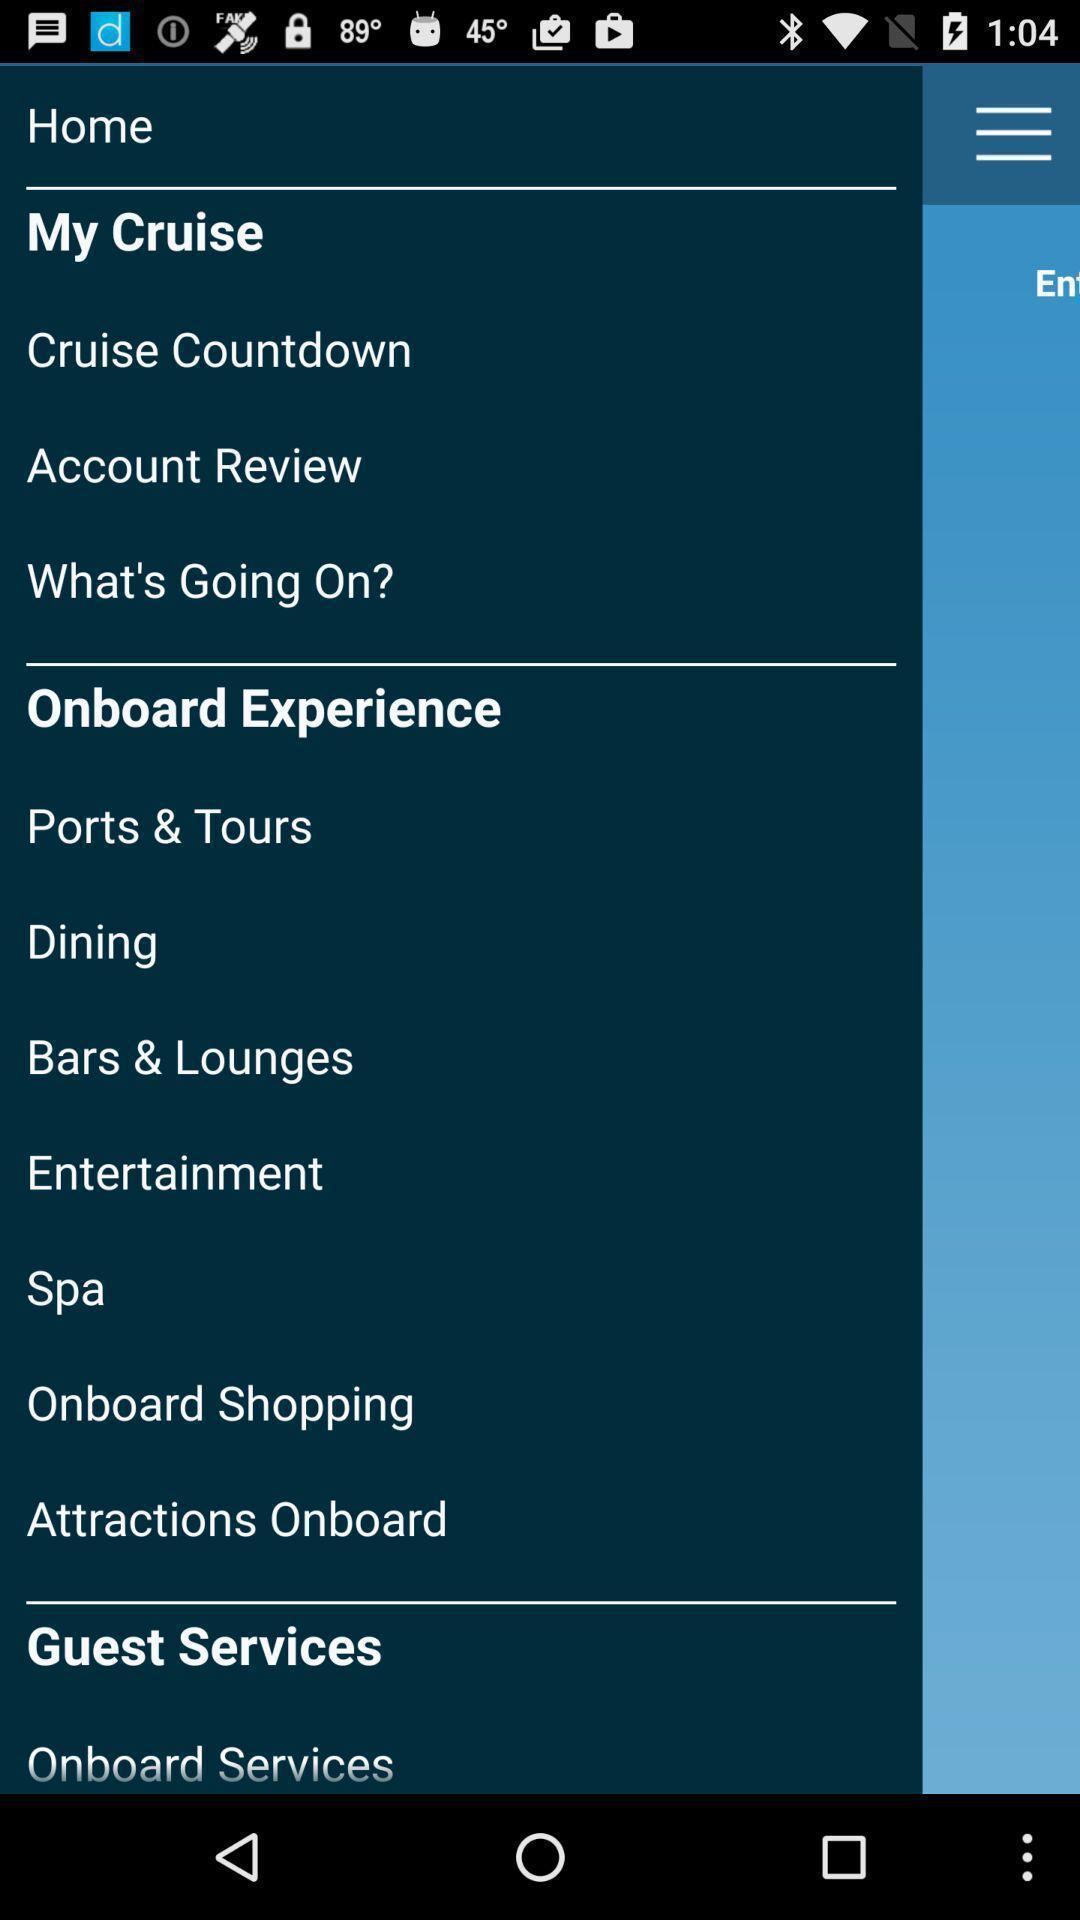Please provide a description for this image. Pop-up showing the home page options. 